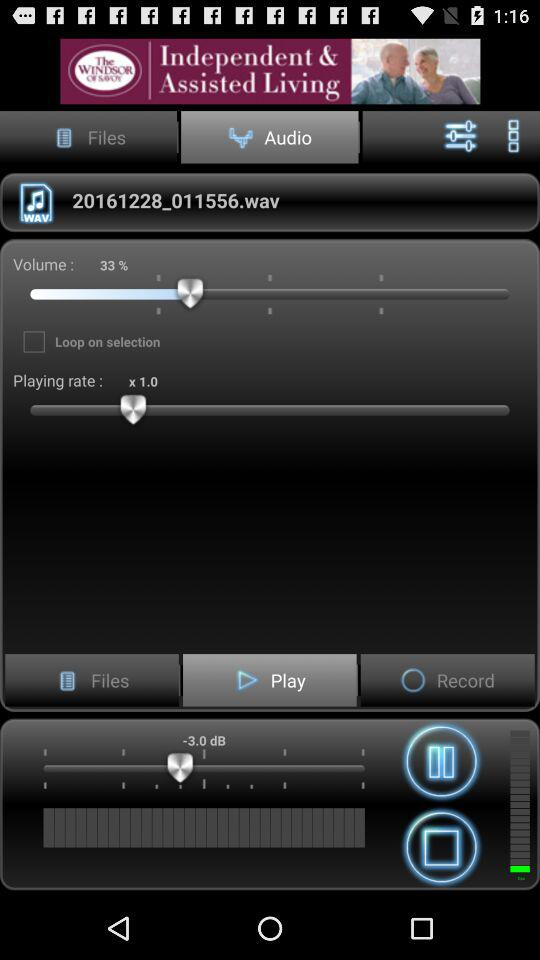What is the selected tab? The selected tab is "Audio". 